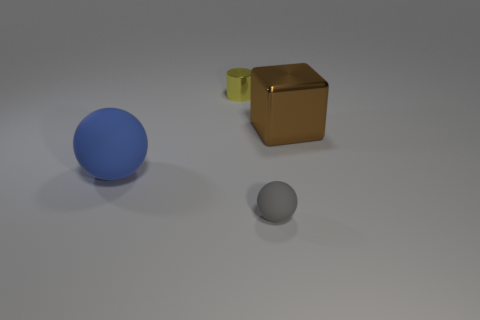Add 3 brown objects. How many objects exist? 7 Subtract all cylinders. How many objects are left? 3 Subtract 1 cylinders. How many cylinders are left? 0 Subtract 1 yellow cylinders. How many objects are left? 3 Subtract all large balls. Subtract all large purple metallic blocks. How many objects are left? 3 Add 1 blocks. How many blocks are left? 2 Add 1 brown shiny objects. How many brown shiny objects exist? 2 